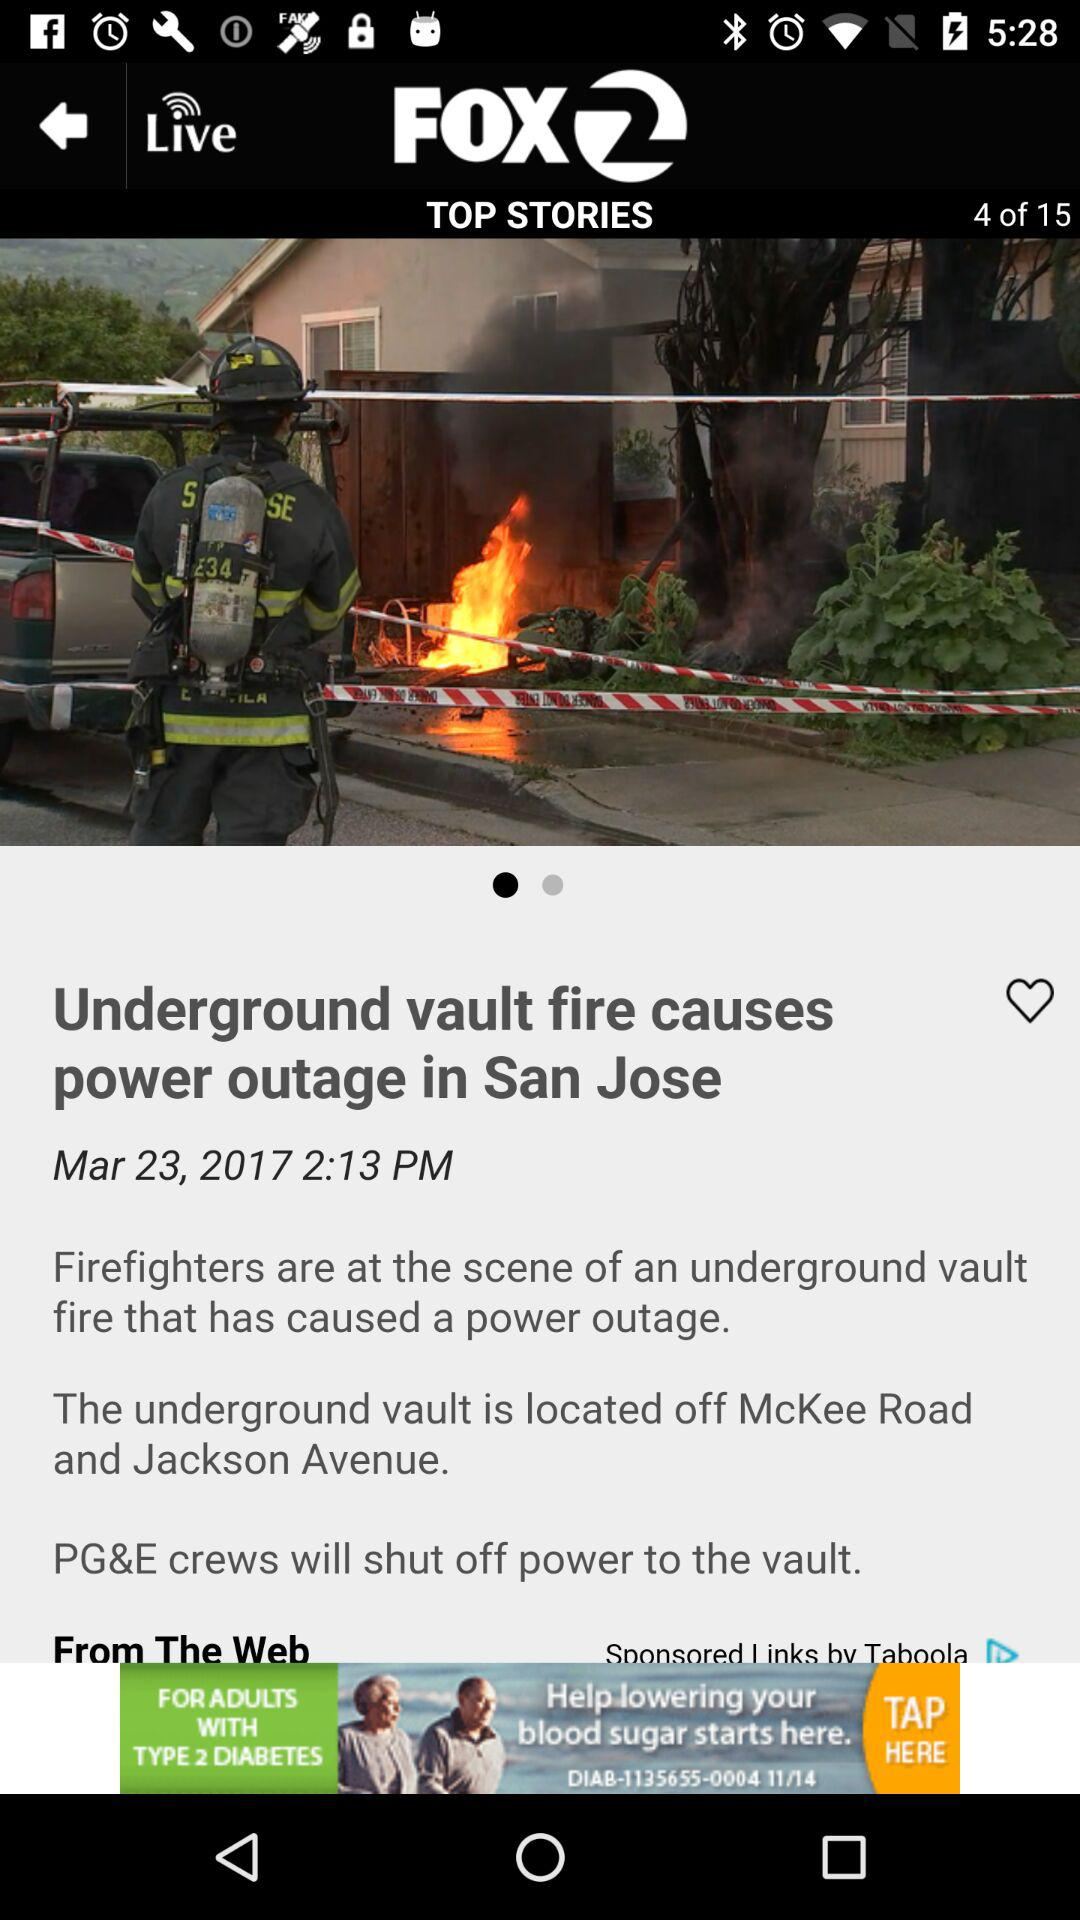On which date is the story "Underground vault fire causes power outage in San Jose" updated? The date is March 23, 2017. 